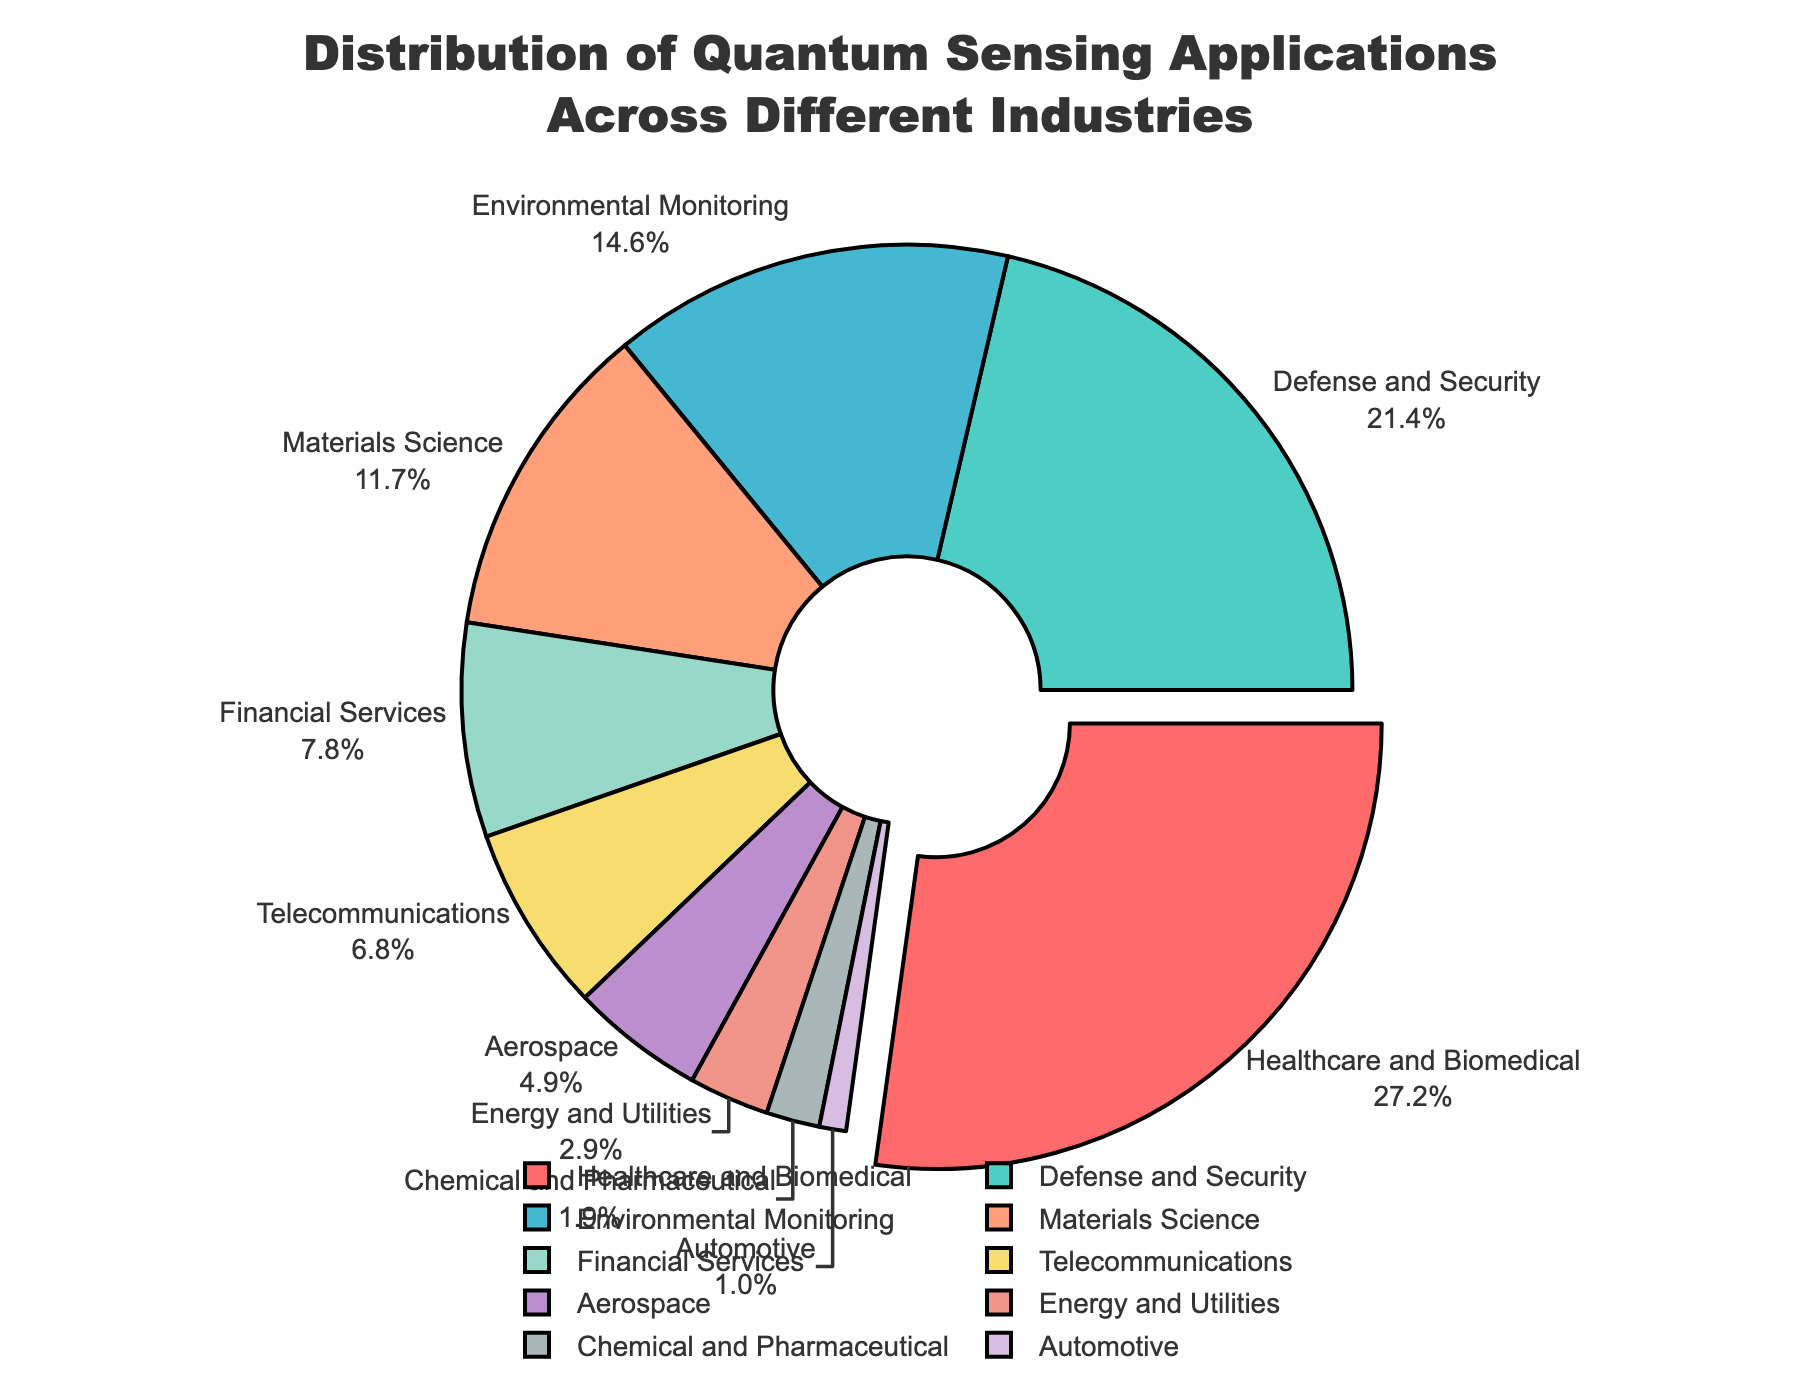What percentage of the quantum sensing applications are in the Healthcare and Biomedical industry? Look at the pie chart segment labeled "Healthcare and Biomedical" and read the percentage value provided.
Answer: 28% Which industry has the smallest share of quantum sensing applications and what is its percentage? Identify the segment with the smallest area and read its label and percentage value.
Answer: Automotive, 1% How many industries have a percentage that is greater than 10%? Count the number of segments with a percentage value higher than 10%.
Answer: 4 What is the combined percentage of quantum sensing applications in the Defense and Security, and Environmental Monitoring industries? Add the percentages of Defense and Security (22%) and Environmental Monitoring (15%).
Answer: 37% Does the Telecommunications industry have a higher or lower percentage of applications compared to the Financial Services industry? Compare the percentages of Telecommunications (7%) and Financial Services (8%).
Answer: Lower Which industry is represented by the darkest segment, and what is its percentage? Identify the visually darkest pie chart segment and read its label and percentage.
Answer: Healthcare and Biomedical, 28% What is the difference in percentage points between the industry with the highest and the industry with the lowest share of quantum sensing applications? Subtract the percentage of the smallest segment (1%) from the largest segment (28%).
Answer: 27 If the total number of quantum sensing applications is 1000, how many of these applications are in the Aerospace industry? Calculate 5% of 1000.
Answer: 50 What is the color associated with the Financial Services industry in the pie chart? Identify the color of the segment labeled "Financial Services".
Answer: Yellow 